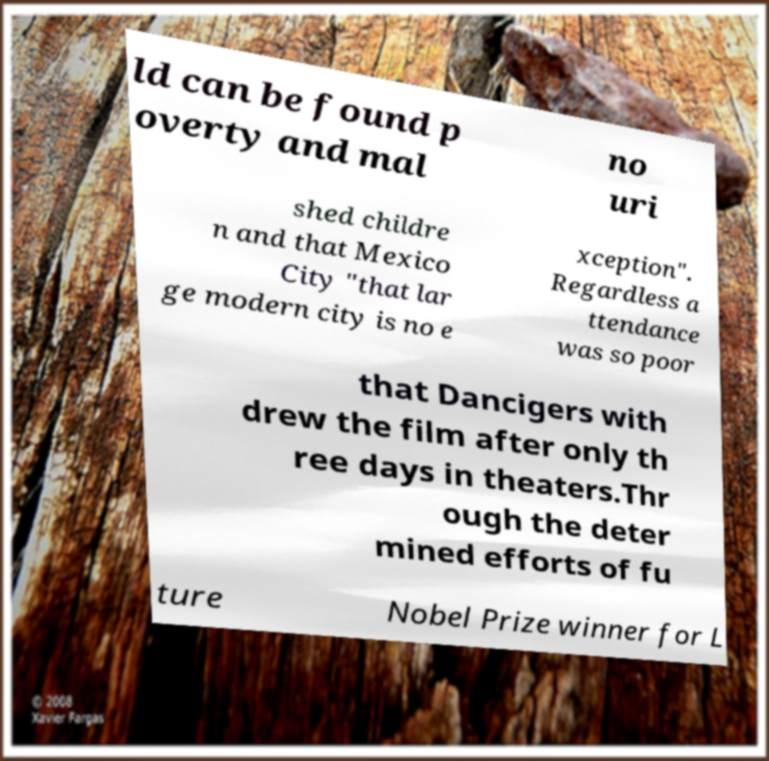For documentation purposes, I need the text within this image transcribed. Could you provide that? ld can be found p overty and mal no uri shed childre n and that Mexico City "that lar ge modern city is no e xception". Regardless a ttendance was so poor that Dancigers with drew the film after only th ree days in theaters.Thr ough the deter mined efforts of fu ture Nobel Prize winner for L 